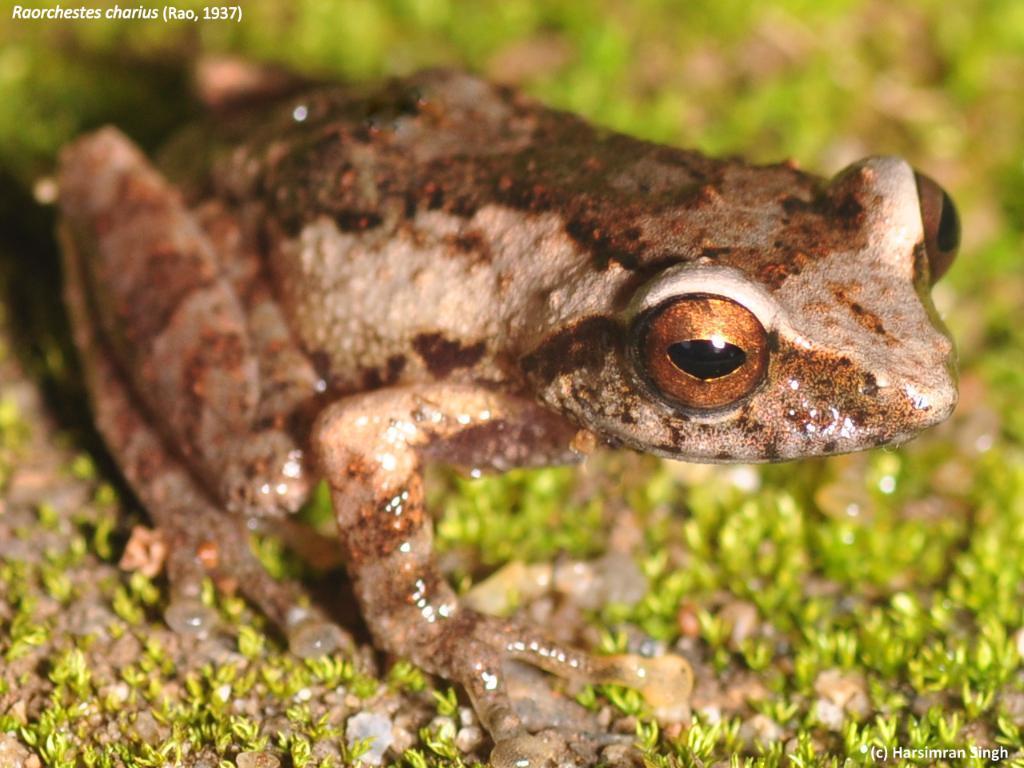In one or two sentences, can you explain what this image depicts? In this image I can see the ground, some grass on the ground and a frog which is cream, brown and black in color. 